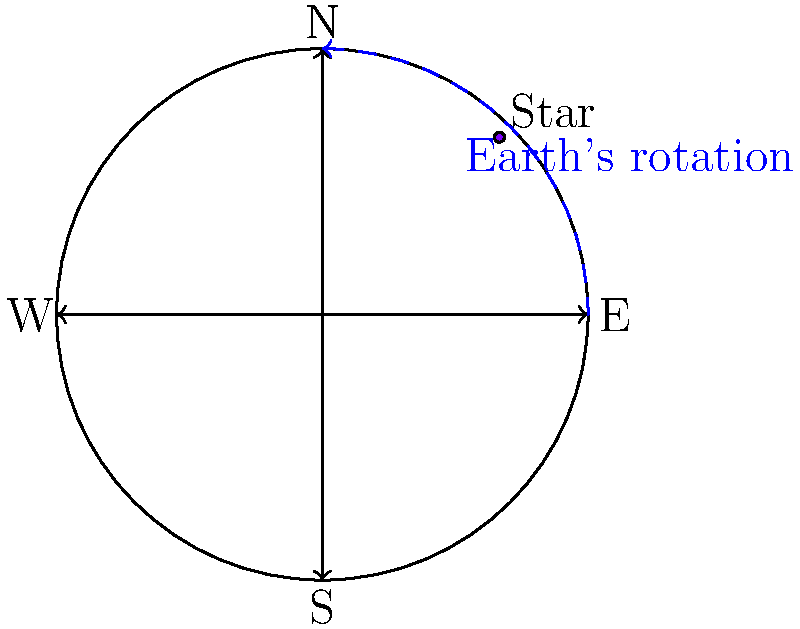As an IT expert implementing secure communication systems for the police department, you need to understand basic principles of astronomy for potential night operations. Consider the apparent motion of stars in the night sky. If a star is observed at the position shown in the diagram, in which direction will it appear to move over the course of a few hours due to Earth's rotation? To understand the apparent motion of stars, we need to consider the following steps:

1. Earth's rotation: The Earth rotates on its axis from west to east, completing one full rotation in approximately 24 hours.

2. Observer's perspective: An observer on Earth's surface perceives this rotation as the celestial sphere (including stars) moving in the opposite direction.

3. Direction of apparent motion: From the observer's point of view, celestial objects appear to move from east to west across the sky.

4. Northern Hemisphere perspective: The diagram shows a view of the night sky from the Northern Hemisphere, with the North celestial pole at the center.

5. Star's position: The star is located in the northeastern part of the sky (between North and East).

6. Circular path: Stars appear to move in circular paths around the celestial pole due to Earth's rotation.

7. Direction of movement: Given the star's position and the direction of Earth's rotation, the star will appear to move counterclockwise around the North celestial pole.

8. Observed motion: From the observer's perspective, this counterclockwise motion will cause the star to move towards the northwest.

Therefore, the star will appear to move from its current position towards the northwest over the course of a few hours.
Answer: Northwest 